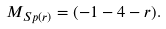<formula> <loc_0><loc_0><loc_500><loc_500>M _ { S p ( r ) } = ( - 1 - 4 - r ) .</formula> 